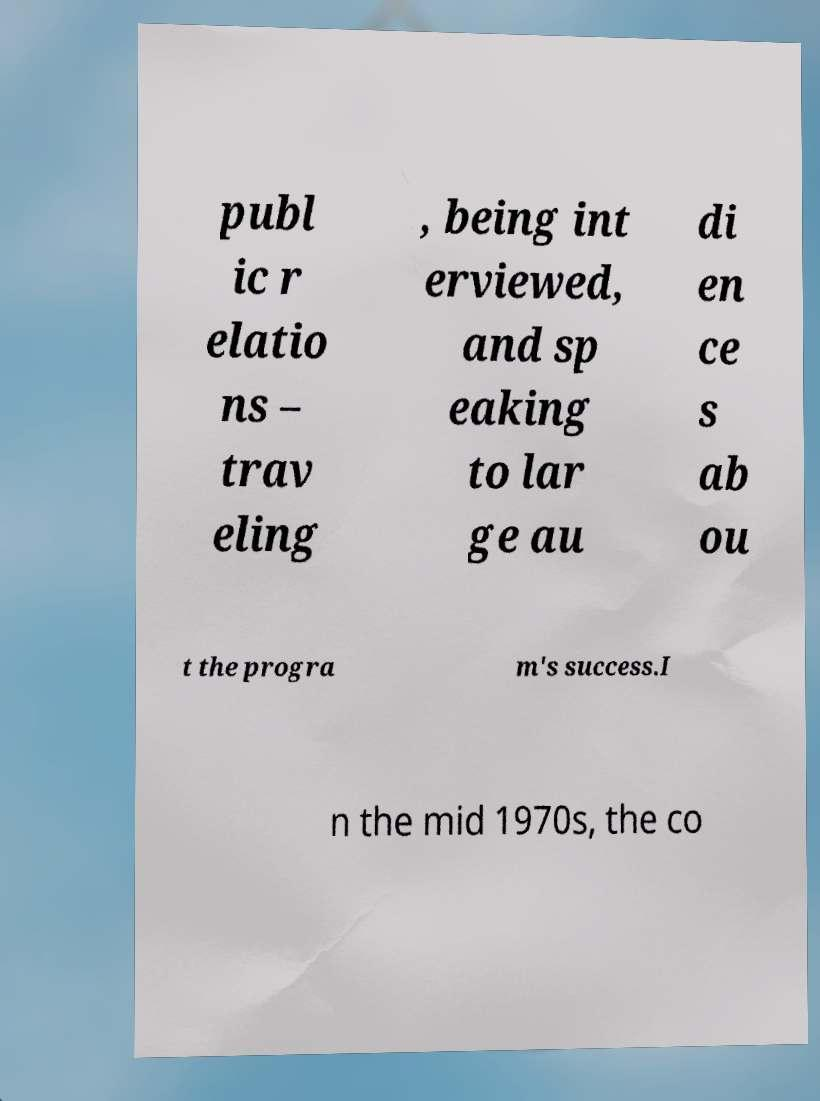Please identify and transcribe the text found in this image. publ ic r elatio ns – trav eling , being int erviewed, and sp eaking to lar ge au di en ce s ab ou t the progra m's success.I n the mid 1970s, the co 